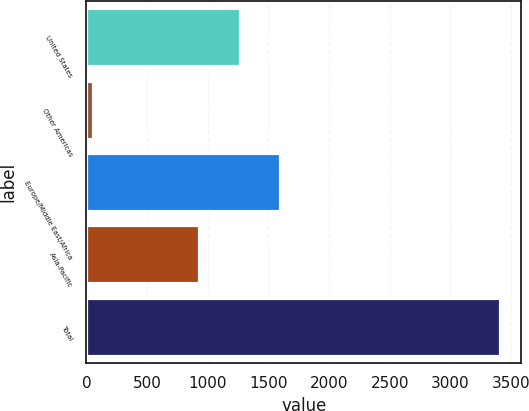<chart> <loc_0><loc_0><loc_500><loc_500><bar_chart><fcel>United States<fcel>Other Americas<fcel>Europe/Middle East/Africa<fcel>Asia-Pacific<fcel>Total<nl><fcel>1262<fcel>52<fcel>1598<fcel>926<fcel>3412<nl></chart> 